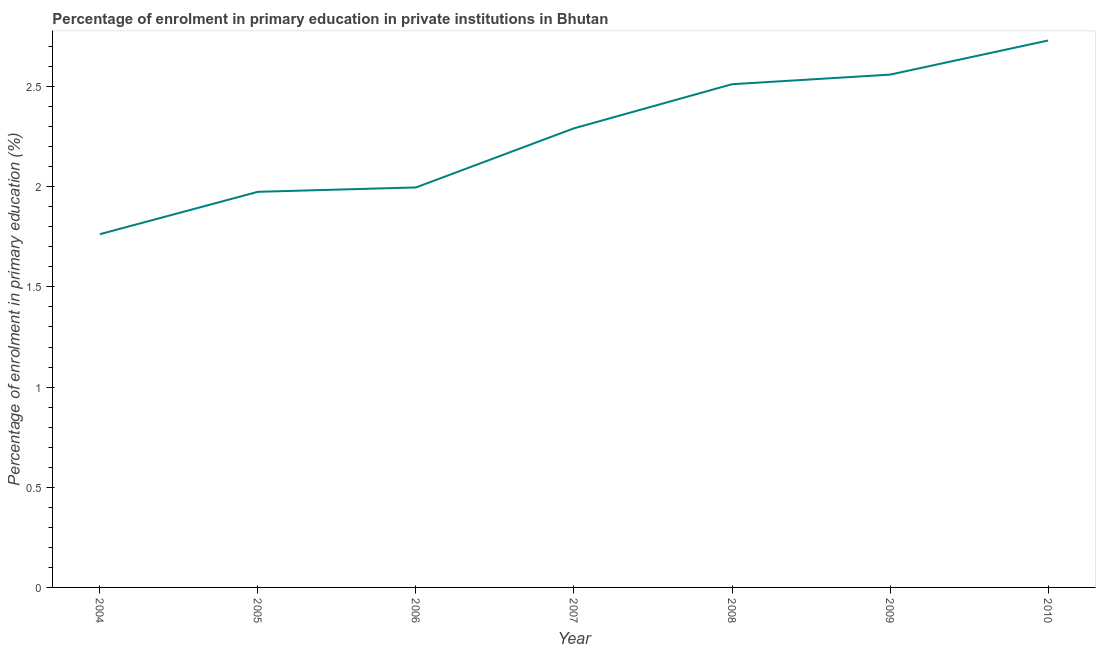What is the enrolment percentage in primary education in 2004?
Ensure brevity in your answer.  1.76. Across all years, what is the maximum enrolment percentage in primary education?
Provide a short and direct response. 2.73. Across all years, what is the minimum enrolment percentage in primary education?
Ensure brevity in your answer.  1.76. In which year was the enrolment percentage in primary education maximum?
Offer a terse response. 2010. In which year was the enrolment percentage in primary education minimum?
Offer a terse response. 2004. What is the sum of the enrolment percentage in primary education?
Your answer should be compact. 15.83. What is the difference between the enrolment percentage in primary education in 2006 and 2007?
Offer a very short reply. -0.3. What is the average enrolment percentage in primary education per year?
Provide a succinct answer. 2.26. What is the median enrolment percentage in primary education?
Provide a short and direct response. 2.29. In how many years, is the enrolment percentage in primary education greater than 2.1 %?
Your answer should be compact. 4. Do a majority of the years between 2005 and 2007 (inclusive) have enrolment percentage in primary education greater than 0.30000000000000004 %?
Make the answer very short. Yes. What is the ratio of the enrolment percentage in primary education in 2004 to that in 2005?
Offer a very short reply. 0.89. Is the enrolment percentage in primary education in 2006 less than that in 2008?
Provide a succinct answer. Yes. What is the difference between the highest and the second highest enrolment percentage in primary education?
Make the answer very short. 0.17. Is the sum of the enrolment percentage in primary education in 2007 and 2009 greater than the maximum enrolment percentage in primary education across all years?
Keep it short and to the point. Yes. What is the difference between the highest and the lowest enrolment percentage in primary education?
Give a very brief answer. 0.97. In how many years, is the enrolment percentage in primary education greater than the average enrolment percentage in primary education taken over all years?
Provide a succinct answer. 4. Does the enrolment percentage in primary education monotonically increase over the years?
Offer a terse response. Yes. How many lines are there?
Give a very brief answer. 1. How many years are there in the graph?
Keep it short and to the point. 7. What is the title of the graph?
Offer a very short reply. Percentage of enrolment in primary education in private institutions in Bhutan. What is the label or title of the Y-axis?
Your answer should be compact. Percentage of enrolment in primary education (%). What is the Percentage of enrolment in primary education (%) in 2004?
Your answer should be compact. 1.76. What is the Percentage of enrolment in primary education (%) in 2005?
Provide a succinct answer. 1.97. What is the Percentage of enrolment in primary education (%) of 2006?
Keep it short and to the point. 2. What is the Percentage of enrolment in primary education (%) in 2007?
Provide a short and direct response. 2.29. What is the Percentage of enrolment in primary education (%) of 2008?
Provide a succinct answer. 2.51. What is the Percentage of enrolment in primary education (%) of 2009?
Ensure brevity in your answer.  2.56. What is the Percentage of enrolment in primary education (%) in 2010?
Your answer should be compact. 2.73. What is the difference between the Percentage of enrolment in primary education (%) in 2004 and 2005?
Keep it short and to the point. -0.21. What is the difference between the Percentage of enrolment in primary education (%) in 2004 and 2006?
Provide a short and direct response. -0.23. What is the difference between the Percentage of enrolment in primary education (%) in 2004 and 2007?
Your response must be concise. -0.53. What is the difference between the Percentage of enrolment in primary education (%) in 2004 and 2008?
Keep it short and to the point. -0.75. What is the difference between the Percentage of enrolment in primary education (%) in 2004 and 2009?
Your answer should be compact. -0.8. What is the difference between the Percentage of enrolment in primary education (%) in 2004 and 2010?
Make the answer very short. -0.97. What is the difference between the Percentage of enrolment in primary education (%) in 2005 and 2006?
Offer a very short reply. -0.02. What is the difference between the Percentage of enrolment in primary education (%) in 2005 and 2007?
Your answer should be compact. -0.32. What is the difference between the Percentage of enrolment in primary education (%) in 2005 and 2008?
Offer a terse response. -0.54. What is the difference between the Percentage of enrolment in primary education (%) in 2005 and 2009?
Ensure brevity in your answer.  -0.58. What is the difference between the Percentage of enrolment in primary education (%) in 2005 and 2010?
Make the answer very short. -0.76. What is the difference between the Percentage of enrolment in primary education (%) in 2006 and 2007?
Make the answer very short. -0.3. What is the difference between the Percentage of enrolment in primary education (%) in 2006 and 2008?
Ensure brevity in your answer.  -0.52. What is the difference between the Percentage of enrolment in primary education (%) in 2006 and 2009?
Your answer should be very brief. -0.56. What is the difference between the Percentage of enrolment in primary education (%) in 2006 and 2010?
Your answer should be compact. -0.73. What is the difference between the Percentage of enrolment in primary education (%) in 2007 and 2008?
Your answer should be compact. -0.22. What is the difference between the Percentage of enrolment in primary education (%) in 2007 and 2009?
Your answer should be very brief. -0.27. What is the difference between the Percentage of enrolment in primary education (%) in 2007 and 2010?
Keep it short and to the point. -0.44. What is the difference between the Percentage of enrolment in primary education (%) in 2008 and 2009?
Offer a terse response. -0.05. What is the difference between the Percentage of enrolment in primary education (%) in 2008 and 2010?
Give a very brief answer. -0.22. What is the difference between the Percentage of enrolment in primary education (%) in 2009 and 2010?
Ensure brevity in your answer.  -0.17. What is the ratio of the Percentage of enrolment in primary education (%) in 2004 to that in 2005?
Offer a terse response. 0.89. What is the ratio of the Percentage of enrolment in primary education (%) in 2004 to that in 2006?
Give a very brief answer. 0.88. What is the ratio of the Percentage of enrolment in primary education (%) in 2004 to that in 2007?
Offer a terse response. 0.77. What is the ratio of the Percentage of enrolment in primary education (%) in 2004 to that in 2008?
Provide a succinct answer. 0.7. What is the ratio of the Percentage of enrolment in primary education (%) in 2004 to that in 2009?
Ensure brevity in your answer.  0.69. What is the ratio of the Percentage of enrolment in primary education (%) in 2004 to that in 2010?
Make the answer very short. 0.65. What is the ratio of the Percentage of enrolment in primary education (%) in 2005 to that in 2007?
Ensure brevity in your answer.  0.86. What is the ratio of the Percentage of enrolment in primary education (%) in 2005 to that in 2008?
Offer a terse response. 0.79. What is the ratio of the Percentage of enrolment in primary education (%) in 2005 to that in 2009?
Your answer should be very brief. 0.77. What is the ratio of the Percentage of enrolment in primary education (%) in 2005 to that in 2010?
Your answer should be very brief. 0.72. What is the ratio of the Percentage of enrolment in primary education (%) in 2006 to that in 2007?
Keep it short and to the point. 0.87. What is the ratio of the Percentage of enrolment in primary education (%) in 2006 to that in 2008?
Give a very brief answer. 0.8. What is the ratio of the Percentage of enrolment in primary education (%) in 2006 to that in 2009?
Your answer should be very brief. 0.78. What is the ratio of the Percentage of enrolment in primary education (%) in 2006 to that in 2010?
Your answer should be compact. 0.73. What is the ratio of the Percentage of enrolment in primary education (%) in 2007 to that in 2008?
Offer a terse response. 0.91. What is the ratio of the Percentage of enrolment in primary education (%) in 2007 to that in 2009?
Give a very brief answer. 0.9. What is the ratio of the Percentage of enrolment in primary education (%) in 2007 to that in 2010?
Your response must be concise. 0.84. What is the ratio of the Percentage of enrolment in primary education (%) in 2008 to that in 2009?
Ensure brevity in your answer.  0.98. What is the ratio of the Percentage of enrolment in primary education (%) in 2008 to that in 2010?
Your response must be concise. 0.92. What is the ratio of the Percentage of enrolment in primary education (%) in 2009 to that in 2010?
Provide a succinct answer. 0.94. 